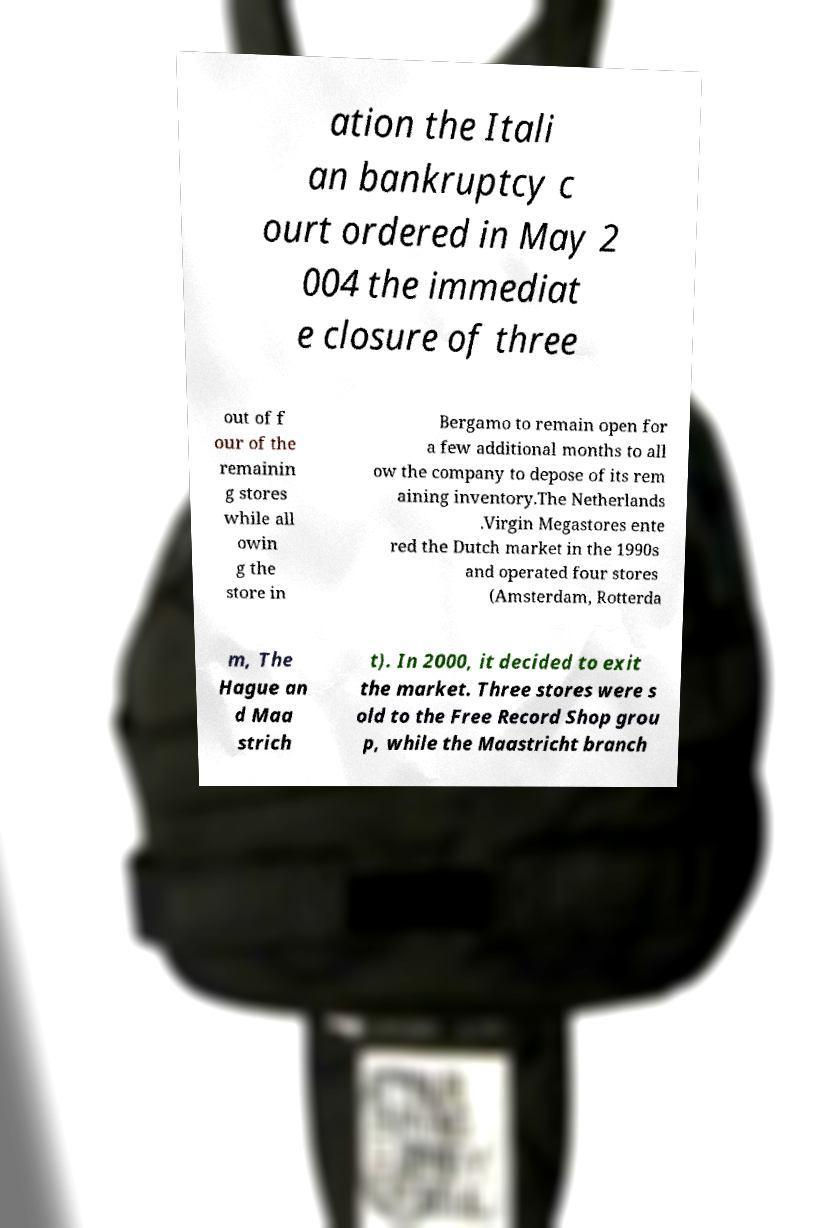What messages or text are displayed in this image? I need them in a readable, typed format. ation the Itali an bankruptcy c ourt ordered in May 2 004 the immediat e closure of three out of f our of the remainin g stores while all owin g the store in Bergamo to remain open for a few additional months to all ow the company to depose of its rem aining inventory.The Netherlands .Virgin Megastores ente red the Dutch market in the 1990s and operated four stores (Amsterdam, Rotterda m, The Hague an d Maa strich t). In 2000, it decided to exit the market. Three stores were s old to the Free Record Shop grou p, while the Maastricht branch 